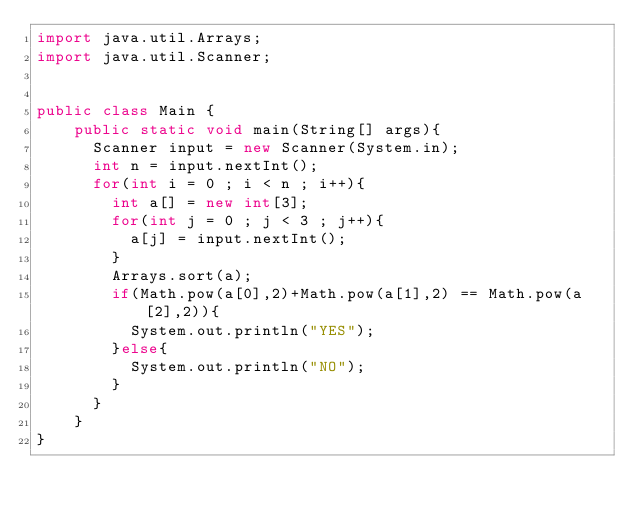Convert code to text. <code><loc_0><loc_0><loc_500><loc_500><_Java_>import java.util.Arrays;
import java.util.Scanner;


public class Main {
    public static void main(String[] args){
    	Scanner input = new Scanner(System.in);
    	int n = input.nextInt();
    	for(int i = 0 ; i < n ; i++){
    		int a[] = new int[3];
    		for(int j = 0 ; j < 3 ; j++){
    			a[j] = input.nextInt();
    		}
    		Arrays.sort(a);
    		if(Math.pow(a[0],2)+Math.pow(a[1],2) == Math.pow(a[2],2)){
    			System.out.println("YES");
    		}else{
    			System.out.println("NO");
    		}
    	}
    }
}</code> 